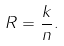<formula> <loc_0><loc_0><loc_500><loc_500>R = \frac { k } { n } .</formula> 